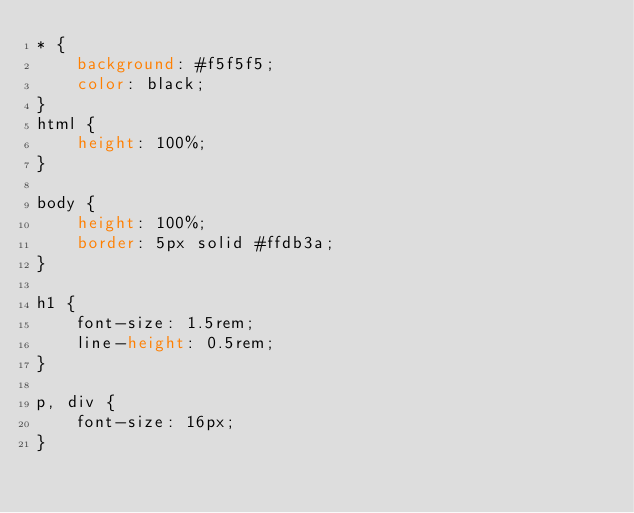<code> <loc_0><loc_0><loc_500><loc_500><_CSS_>* {
    background: #f5f5f5;
    color: black;
}
html { 
    height: 100%;
}

body { 
    height: 100%;
    border: 5px solid #ffdb3a;
}

h1 {
    font-size: 1.5rem;
    line-height: 0.5rem;
}

p, div {
    font-size: 16px;
}
</code> 